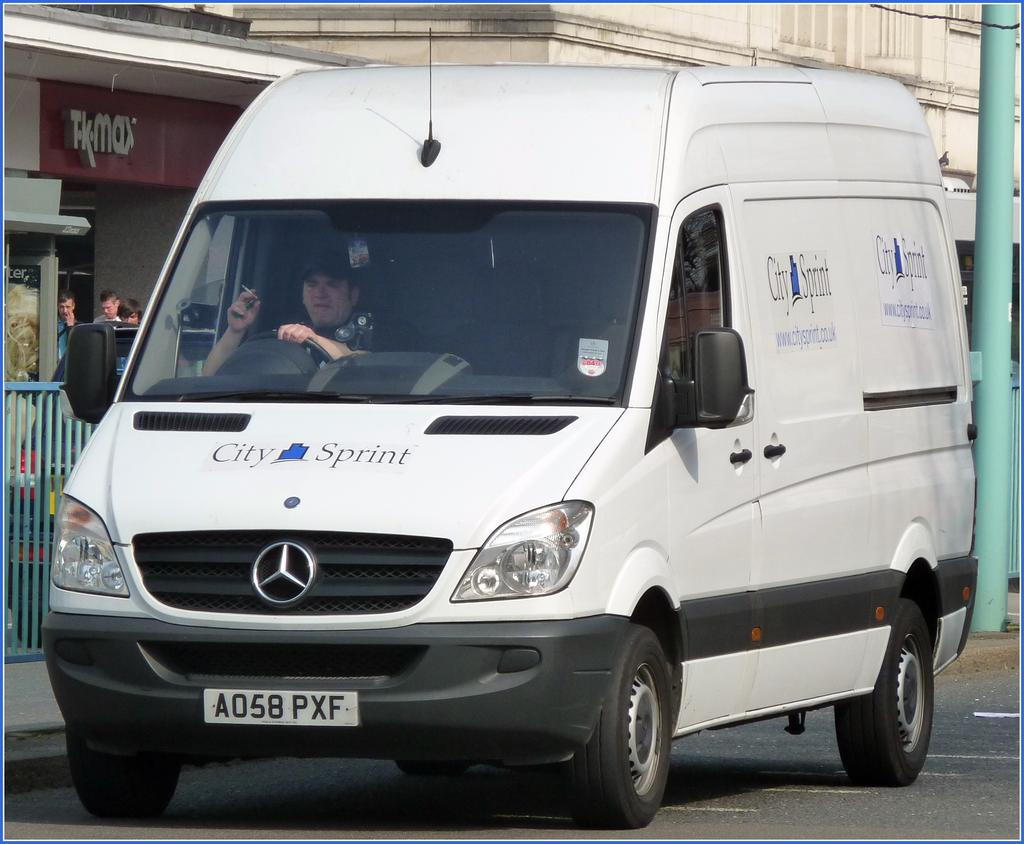<image>
Write a terse but informative summary of the picture. A man sits inside of a City Spirit van smoking a cigarette. 